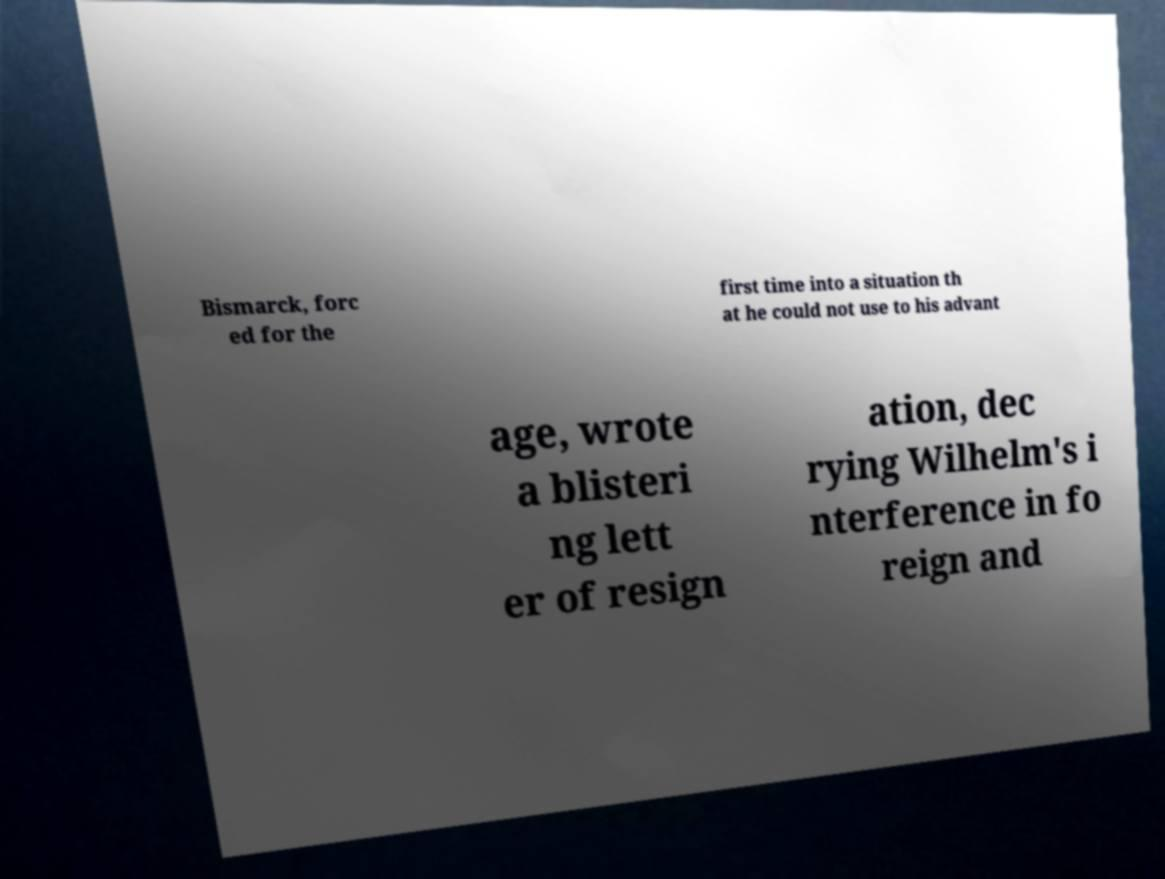Can you accurately transcribe the text from the provided image for me? Bismarck, forc ed for the first time into a situation th at he could not use to his advant age, wrote a blisteri ng lett er of resign ation, dec rying Wilhelm's i nterference in fo reign and 